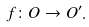Convert formula to latex. <formula><loc_0><loc_0><loc_500><loc_500>f \colon O \to O ^ { \prime } .</formula> 